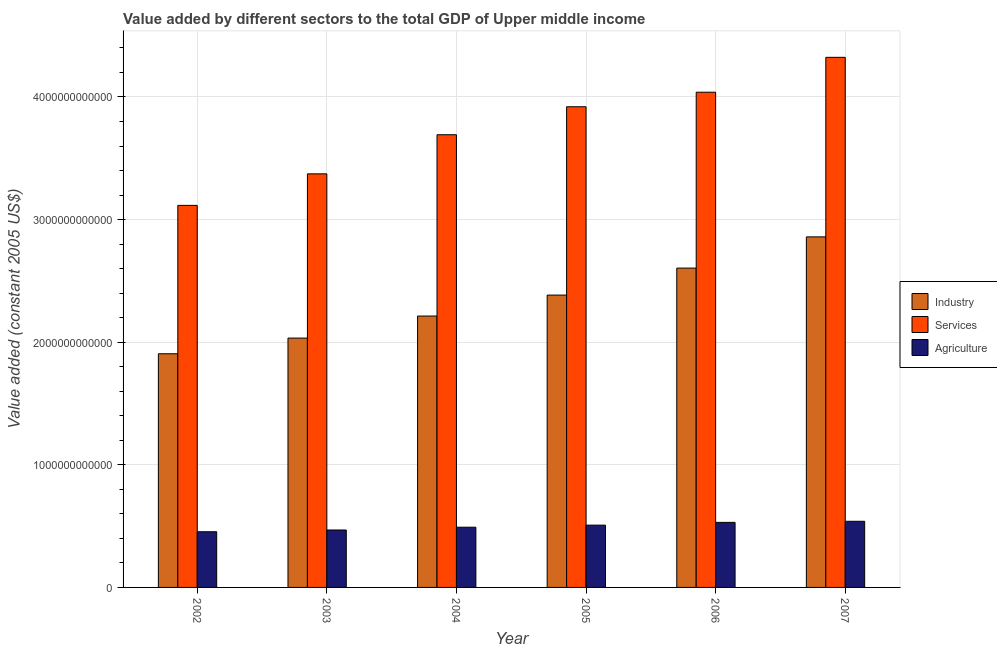How many different coloured bars are there?
Your answer should be compact. 3. How many groups of bars are there?
Give a very brief answer. 6. Are the number of bars per tick equal to the number of legend labels?
Give a very brief answer. Yes. Are the number of bars on each tick of the X-axis equal?
Keep it short and to the point. Yes. How many bars are there on the 6th tick from the right?
Keep it short and to the point. 3. What is the label of the 4th group of bars from the left?
Keep it short and to the point. 2005. What is the value added by agricultural sector in 2006?
Your answer should be very brief. 5.30e+11. Across all years, what is the maximum value added by services?
Offer a very short reply. 4.32e+12. Across all years, what is the minimum value added by industrial sector?
Provide a short and direct response. 1.91e+12. In which year was the value added by services maximum?
Your response must be concise. 2007. In which year was the value added by services minimum?
Give a very brief answer. 2002. What is the total value added by industrial sector in the graph?
Offer a terse response. 1.40e+13. What is the difference between the value added by industrial sector in 2004 and that in 2005?
Give a very brief answer. -1.71e+11. What is the difference between the value added by agricultural sector in 2007 and the value added by industrial sector in 2003?
Offer a terse response. 7.10e+1. What is the average value added by services per year?
Ensure brevity in your answer.  3.74e+12. In the year 2005, what is the difference between the value added by services and value added by agricultural sector?
Make the answer very short. 0. What is the ratio of the value added by services in 2003 to that in 2005?
Give a very brief answer. 0.86. Is the difference between the value added by services in 2004 and 2005 greater than the difference between the value added by industrial sector in 2004 and 2005?
Give a very brief answer. No. What is the difference between the highest and the second highest value added by agricultural sector?
Give a very brief answer. 8.90e+09. What is the difference between the highest and the lowest value added by services?
Provide a short and direct response. 1.21e+12. Is the sum of the value added by industrial sector in 2002 and 2006 greater than the maximum value added by agricultural sector across all years?
Offer a very short reply. Yes. What does the 3rd bar from the left in 2006 represents?
Keep it short and to the point. Agriculture. What does the 2nd bar from the right in 2006 represents?
Your answer should be compact. Services. Is it the case that in every year, the sum of the value added by industrial sector and value added by services is greater than the value added by agricultural sector?
Offer a very short reply. Yes. How many bars are there?
Your answer should be very brief. 18. How many years are there in the graph?
Keep it short and to the point. 6. What is the difference between two consecutive major ticks on the Y-axis?
Make the answer very short. 1.00e+12. Are the values on the major ticks of Y-axis written in scientific E-notation?
Offer a terse response. No. Does the graph contain any zero values?
Provide a succinct answer. No. Does the graph contain grids?
Provide a succinct answer. Yes. Where does the legend appear in the graph?
Make the answer very short. Center right. How many legend labels are there?
Your answer should be very brief. 3. How are the legend labels stacked?
Give a very brief answer. Vertical. What is the title of the graph?
Your response must be concise. Value added by different sectors to the total GDP of Upper middle income. What is the label or title of the Y-axis?
Provide a short and direct response. Value added (constant 2005 US$). What is the Value added (constant 2005 US$) in Industry in 2002?
Your answer should be very brief. 1.91e+12. What is the Value added (constant 2005 US$) in Services in 2002?
Offer a very short reply. 3.12e+12. What is the Value added (constant 2005 US$) in Agriculture in 2002?
Your response must be concise. 4.54e+11. What is the Value added (constant 2005 US$) in Industry in 2003?
Provide a short and direct response. 2.03e+12. What is the Value added (constant 2005 US$) of Services in 2003?
Keep it short and to the point. 3.37e+12. What is the Value added (constant 2005 US$) in Agriculture in 2003?
Ensure brevity in your answer.  4.68e+11. What is the Value added (constant 2005 US$) in Industry in 2004?
Give a very brief answer. 2.21e+12. What is the Value added (constant 2005 US$) of Services in 2004?
Keep it short and to the point. 3.69e+12. What is the Value added (constant 2005 US$) of Agriculture in 2004?
Keep it short and to the point. 4.91e+11. What is the Value added (constant 2005 US$) in Industry in 2005?
Your response must be concise. 2.38e+12. What is the Value added (constant 2005 US$) in Services in 2005?
Offer a very short reply. 3.92e+12. What is the Value added (constant 2005 US$) of Agriculture in 2005?
Provide a short and direct response. 5.08e+11. What is the Value added (constant 2005 US$) of Industry in 2006?
Make the answer very short. 2.60e+12. What is the Value added (constant 2005 US$) of Services in 2006?
Make the answer very short. 4.04e+12. What is the Value added (constant 2005 US$) of Agriculture in 2006?
Your answer should be very brief. 5.30e+11. What is the Value added (constant 2005 US$) of Industry in 2007?
Provide a short and direct response. 2.86e+12. What is the Value added (constant 2005 US$) of Services in 2007?
Your response must be concise. 4.32e+12. What is the Value added (constant 2005 US$) of Agriculture in 2007?
Your answer should be compact. 5.39e+11. Across all years, what is the maximum Value added (constant 2005 US$) of Industry?
Provide a short and direct response. 2.86e+12. Across all years, what is the maximum Value added (constant 2005 US$) of Services?
Your answer should be very brief. 4.32e+12. Across all years, what is the maximum Value added (constant 2005 US$) in Agriculture?
Your answer should be compact. 5.39e+11. Across all years, what is the minimum Value added (constant 2005 US$) of Industry?
Keep it short and to the point. 1.91e+12. Across all years, what is the minimum Value added (constant 2005 US$) of Services?
Your answer should be very brief. 3.12e+12. Across all years, what is the minimum Value added (constant 2005 US$) of Agriculture?
Provide a short and direct response. 4.54e+11. What is the total Value added (constant 2005 US$) in Industry in the graph?
Provide a succinct answer. 1.40e+13. What is the total Value added (constant 2005 US$) of Services in the graph?
Keep it short and to the point. 2.25e+13. What is the total Value added (constant 2005 US$) of Agriculture in the graph?
Your answer should be very brief. 2.99e+12. What is the difference between the Value added (constant 2005 US$) in Industry in 2002 and that in 2003?
Offer a terse response. -1.28e+11. What is the difference between the Value added (constant 2005 US$) of Services in 2002 and that in 2003?
Keep it short and to the point. -2.57e+11. What is the difference between the Value added (constant 2005 US$) of Agriculture in 2002 and that in 2003?
Offer a very short reply. -1.43e+1. What is the difference between the Value added (constant 2005 US$) of Industry in 2002 and that in 2004?
Your answer should be very brief. -3.08e+11. What is the difference between the Value added (constant 2005 US$) in Services in 2002 and that in 2004?
Offer a very short reply. -5.76e+11. What is the difference between the Value added (constant 2005 US$) of Agriculture in 2002 and that in 2004?
Your answer should be very brief. -3.70e+1. What is the difference between the Value added (constant 2005 US$) in Industry in 2002 and that in 2005?
Offer a terse response. -4.79e+11. What is the difference between the Value added (constant 2005 US$) in Services in 2002 and that in 2005?
Your response must be concise. -8.04e+11. What is the difference between the Value added (constant 2005 US$) of Agriculture in 2002 and that in 2005?
Offer a terse response. -5.39e+1. What is the difference between the Value added (constant 2005 US$) of Industry in 2002 and that in 2006?
Your response must be concise. -6.99e+11. What is the difference between the Value added (constant 2005 US$) in Services in 2002 and that in 2006?
Offer a terse response. -9.23e+11. What is the difference between the Value added (constant 2005 US$) in Agriculture in 2002 and that in 2006?
Ensure brevity in your answer.  -7.63e+1. What is the difference between the Value added (constant 2005 US$) of Industry in 2002 and that in 2007?
Offer a terse response. -9.53e+11. What is the difference between the Value added (constant 2005 US$) in Services in 2002 and that in 2007?
Offer a terse response. -1.21e+12. What is the difference between the Value added (constant 2005 US$) in Agriculture in 2002 and that in 2007?
Keep it short and to the point. -8.52e+1. What is the difference between the Value added (constant 2005 US$) in Industry in 2003 and that in 2004?
Your answer should be compact. -1.80e+11. What is the difference between the Value added (constant 2005 US$) of Services in 2003 and that in 2004?
Make the answer very short. -3.19e+11. What is the difference between the Value added (constant 2005 US$) in Agriculture in 2003 and that in 2004?
Give a very brief answer. -2.27e+1. What is the difference between the Value added (constant 2005 US$) of Industry in 2003 and that in 2005?
Give a very brief answer. -3.51e+11. What is the difference between the Value added (constant 2005 US$) in Services in 2003 and that in 2005?
Your response must be concise. -5.47e+11. What is the difference between the Value added (constant 2005 US$) in Agriculture in 2003 and that in 2005?
Provide a short and direct response. -3.96e+1. What is the difference between the Value added (constant 2005 US$) in Industry in 2003 and that in 2006?
Offer a very short reply. -5.71e+11. What is the difference between the Value added (constant 2005 US$) in Services in 2003 and that in 2006?
Your answer should be very brief. -6.66e+11. What is the difference between the Value added (constant 2005 US$) in Agriculture in 2003 and that in 2006?
Your answer should be compact. -6.21e+1. What is the difference between the Value added (constant 2005 US$) in Industry in 2003 and that in 2007?
Give a very brief answer. -8.25e+11. What is the difference between the Value added (constant 2005 US$) of Services in 2003 and that in 2007?
Offer a very short reply. -9.50e+11. What is the difference between the Value added (constant 2005 US$) in Agriculture in 2003 and that in 2007?
Provide a short and direct response. -7.10e+1. What is the difference between the Value added (constant 2005 US$) in Industry in 2004 and that in 2005?
Provide a succinct answer. -1.71e+11. What is the difference between the Value added (constant 2005 US$) in Services in 2004 and that in 2005?
Your response must be concise. -2.28e+11. What is the difference between the Value added (constant 2005 US$) in Agriculture in 2004 and that in 2005?
Keep it short and to the point. -1.69e+1. What is the difference between the Value added (constant 2005 US$) of Industry in 2004 and that in 2006?
Keep it short and to the point. -3.91e+11. What is the difference between the Value added (constant 2005 US$) of Services in 2004 and that in 2006?
Ensure brevity in your answer.  -3.47e+11. What is the difference between the Value added (constant 2005 US$) of Agriculture in 2004 and that in 2006?
Provide a succinct answer. -3.94e+1. What is the difference between the Value added (constant 2005 US$) of Industry in 2004 and that in 2007?
Your answer should be very brief. -6.46e+11. What is the difference between the Value added (constant 2005 US$) of Services in 2004 and that in 2007?
Provide a succinct answer. -6.31e+11. What is the difference between the Value added (constant 2005 US$) in Agriculture in 2004 and that in 2007?
Offer a terse response. -4.83e+1. What is the difference between the Value added (constant 2005 US$) of Industry in 2005 and that in 2006?
Keep it short and to the point. -2.20e+11. What is the difference between the Value added (constant 2005 US$) of Services in 2005 and that in 2006?
Ensure brevity in your answer.  -1.19e+11. What is the difference between the Value added (constant 2005 US$) of Agriculture in 2005 and that in 2006?
Give a very brief answer. -2.25e+1. What is the difference between the Value added (constant 2005 US$) in Industry in 2005 and that in 2007?
Provide a succinct answer. -4.75e+11. What is the difference between the Value added (constant 2005 US$) in Services in 2005 and that in 2007?
Your answer should be compact. -4.03e+11. What is the difference between the Value added (constant 2005 US$) in Agriculture in 2005 and that in 2007?
Your response must be concise. -3.14e+1. What is the difference between the Value added (constant 2005 US$) in Industry in 2006 and that in 2007?
Keep it short and to the point. -2.55e+11. What is the difference between the Value added (constant 2005 US$) in Services in 2006 and that in 2007?
Keep it short and to the point. -2.84e+11. What is the difference between the Value added (constant 2005 US$) of Agriculture in 2006 and that in 2007?
Provide a short and direct response. -8.90e+09. What is the difference between the Value added (constant 2005 US$) of Industry in 2002 and the Value added (constant 2005 US$) of Services in 2003?
Offer a very short reply. -1.47e+12. What is the difference between the Value added (constant 2005 US$) of Industry in 2002 and the Value added (constant 2005 US$) of Agriculture in 2003?
Offer a very short reply. 1.44e+12. What is the difference between the Value added (constant 2005 US$) of Services in 2002 and the Value added (constant 2005 US$) of Agriculture in 2003?
Make the answer very short. 2.65e+12. What is the difference between the Value added (constant 2005 US$) in Industry in 2002 and the Value added (constant 2005 US$) in Services in 2004?
Ensure brevity in your answer.  -1.79e+12. What is the difference between the Value added (constant 2005 US$) in Industry in 2002 and the Value added (constant 2005 US$) in Agriculture in 2004?
Your answer should be compact. 1.41e+12. What is the difference between the Value added (constant 2005 US$) in Services in 2002 and the Value added (constant 2005 US$) in Agriculture in 2004?
Your answer should be compact. 2.62e+12. What is the difference between the Value added (constant 2005 US$) of Industry in 2002 and the Value added (constant 2005 US$) of Services in 2005?
Your answer should be compact. -2.01e+12. What is the difference between the Value added (constant 2005 US$) of Industry in 2002 and the Value added (constant 2005 US$) of Agriculture in 2005?
Make the answer very short. 1.40e+12. What is the difference between the Value added (constant 2005 US$) of Services in 2002 and the Value added (constant 2005 US$) of Agriculture in 2005?
Your answer should be compact. 2.61e+12. What is the difference between the Value added (constant 2005 US$) of Industry in 2002 and the Value added (constant 2005 US$) of Services in 2006?
Your answer should be very brief. -2.13e+12. What is the difference between the Value added (constant 2005 US$) in Industry in 2002 and the Value added (constant 2005 US$) in Agriculture in 2006?
Your response must be concise. 1.38e+12. What is the difference between the Value added (constant 2005 US$) in Services in 2002 and the Value added (constant 2005 US$) in Agriculture in 2006?
Make the answer very short. 2.59e+12. What is the difference between the Value added (constant 2005 US$) in Industry in 2002 and the Value added (constant 2005 US$) in Services in 2007?
Your response must be concise. -2.42e+12. What is the difference between the Value added (constant 2005 US$) in Industry in 2002 and the Value added (constant 2005 US$) in Agriculture in 2007?
Your response must be concise. 1.37e+12. What is the difference between the Value added (constant 2005 US$) in Services in 2002 and the Value added (constant 2005 US$) in Agriculture in 2007?
Provide a succinct answer. 2.58e+12. What is the difference between the Value added (constant 2005 US$) in Industry in 2003 and the Value added (constant 2005 US$) in Services in 2004?
Offer a terse response. -1.66e+12. What is the difference between the Value added (constant 2005 US$) of Industry in 2003 and the Value added (constant 2005 US$) of Agriculture in 2004?
Your response must be concise. 1.54e+12. What is the difference between the Value added (constant 2005 US$) of Services in 2003 and the Value added (constant 2005 US$) of Agriculture in 2004?
Offer a very short reply. 2.88e+12. What is the difference between the Value added (constant 2005 US$) of Industry in 2003 and the Value added (constant 2005 US$) of Services in 2005?
Offer a very short reply. -1.89e+12. What is the difference between the Value added (constant 2005 US$) of Industry in 2003 and the Value added (constant 2005 US$) of Agriculture in 2005?
Offer a very short reply. 1.53e+12. What is the difference between the Value added (constant 2005 US$) of Services in 2003 and the Value added (constant 2005 US$) of Agriculture in 2005?
Your response must be concise. 2.87e+12. What is the difference between the Value added (constant 2005 US$) in Industry in 2003 and the Value added (constant 2005 US$) in Services in 2006?
Your answer should be very brief. -2.01e+12. What is the difference between the Value added (constant 2005 US$) of Industry in 2003 and the Value added (constant 2005 US$) of Agriculture in 2006?
Offer a very short reply. 1.50e+12. What is the difference between the Value added (constant 2005 US$) of Services in 2003 and the Value added (constant 2005 US$) of Agriculture in 2006?
Provide a succinct answer. 2.84e+12. What is the difference between the Value added (constant 2005 US$) of Industry in 2003 and the Value added (constant 2005 US$) of Services in 2007?
Provide a short and direct response. -2.29e+12. What is the difference between the Value added (constant 2005 US$) of Industry in 2003 and the Value added (constant 2005 US$) of Agriculture in 2007?
Make the answer very short. 1.49e+12. What is the difference between the Value added (constant 2005 US$) in Services in 2003 and the Value added (constant 2005 US$) in Agriculture in 2007?
Provide a short and direct response. 2.83e+12. What is the difference between the Value added (constant 2005 US$) in Industry in 2004 and the Value added (constant 2005 US$) in Services in 2005?
Offer a very short reply. -1.71e+12. What is the difference between the Value added (constant 2005 US$) of Industry in 2004 and the Value added (constant 2005 US$) of Agriculture in 2005?
Give a very brief answer. 1.71e+12. What is the difference between the Value added (constant 2005 US$) of Services in 2004 and the Value added (constant 2005 US$) of Agriculture in 2005?
Provide a succinct answer. 3.18e+12. What is the difference between the Value added (constant 2005 US$) in Industry in 2004 and the Value added (constant 2005 US$) in Services in 2006?
Your response must be concise. -1.83e+12. What is the difference between the Value added (constant 2005 US$) of Industry in 2004 and the Value added (constant 2005 US$) of Agriculture in 2006?
Provide a succinct answer. 1.68e+12. What is the difference between the Value added (constant 2005 US$) in Services in 2004 and the Value added (constant 2005 US$) in Agriculture in 2006?
Your answer should be compact. 3.16e+12. What is the difference between the Value added (constant 2005 US$) of Industry in 2004 and the Value added (constant 2005 US$) of Services in 2007?
Ensure brevity in your answer.  -2.11e+12. What is the difference between the Value added (constant 2005 US$) in Industry in 2004 and the Value added (constant 2005 US$) in Agriculture in 2007?
Keep it short and to the point. 1.67e+12. What is the difference between the Value added (constant 2005 US$) in Services in 2004 and the Value added (constant 2005 US$) in Agriculture in 2007?
Provide a succinct answer. 3.15e+12. What is the difference between the Value added (constant 2005 US$) of Industry in 2005 and the Value added (constant 2005 US$) of Services in 2006?
Offer a terse response. -1.65e+12. What is the difference between the Value added (constant 2005 US$) in Industry in 2005 and the Value added (constant 2005 US$) in Agriculture in 2006?
Your answer should be compact. 1.85e+12. What is the difference between the Value added (constant 2005 US$) of Services in 2005 and the Value added (constant 2005 US$) of Agriculture in 2006?
Offer a terse response. 3.39e+12. What is the difference between the Value added (constant 2005 US$) in Industry in 2005 and the Value added (constant 2005 US$) in Services in 2007?
Ensure brevity in your answer.  -1.94e+12. What is the difference between the Value added (constant 2005 US$) of Industry in 2005 and the Value added (constant 2005 US$) of Agriculture in 2007?
Offer a terse response. 1.85e+12. What is the difference between the Value added (constant 2005 US$) in Services in 2005 and the Value added (constant 2005 US$) in Agriculture in 2007?
Offer a terse response. 3.38e+12. What is the difference between the Value added (constant 2005 US$) in Industry in 2006 and the Value added (constant 2005 US$) in Services in 2007?
Your answer should be compact. -1.72e+12. What is the difference between the Value added (constant 2005 US$) in Industry in 2006 and the Value added (constant 2005 US$) in Agriculture in 2007?
Provide a short and direct response. 2.07e+12. What is the difference between the Value added (constant 2005 US$) in Services in 2006 and the Value added (constant 2005 US$) in Agriculture in 2007?
Your answer should be compact. 3.50e+12. What is the average Value added (constant 2005 US$) of Industry per year?
Make the answer very short. 2.33e+12. What is the average Value added (constant 2005 US$) in Services per year?
Keep it short and to the point. 3.74e+12. What is the average Value added (constant 2005 US$) in Agriculture per year?
Ensure brevity in your answer.  4.99e+11. In the year 2002, what is the difference between the Value added (constant 2005 US$) of Industry and Value added (constant 2005 US$) of Services?
Keep it short and to the point. -1.21e+12. In the year 2002, what is the difference between the Value added (constant 2005 US$) of Industry and Value added (constant 2005 US$) of Agriculture?
Offer a very short reply. 1.45e+12. In the year 2002, what is the difference between the Value added (constant 2005 US$) of Services and Value added (constant 2005 US$) of Agriculture?
Provide a short and direct response. 2.66e+12. In the year 2003, what is the difference between the Value added (constant 2005 US$) in Industry and Value added (constant 2005 US$) in Services?
Offer a terse response. -1.34e+12. In the year 2003, what is the difference between the Value added (constant 2005 US$) of Industry and Value added (constant 2005 US$) of Agriculture?
Offer a terse response. 1.57e+12. In the year 2003, what is the difference between the Value added (constant 2005 US$) of Services and Value added (constant 2005 US$) of Agriculture?
Your response must be concise. 2.90e+12. In the year 2004, what is the difference between the Value added (constant 2005 US$) of Industry and Value added (constant 2005 US$) of Services?
Provide a succinct answer. -1.48e+12. In the year 2004, what is the difference between the Value added (constant 2005 US$) of Industry and Value added (constant 2005 US$) of Agriculture?
Offer a terse response. 1.72e+12. In the year 2004, what is the difference between the Value added (constant 2005 US$) of Services and Value added (constant 2005 US$) of Agriculture?
Keep it short and to the point. 3.20e+12. In the year 2005, what is the difference between the Value added (constant 2005 US$) in Industry and Value added (constant 2005 US$) in Services?
Offer a terse response. -1.54e+12. In the year 2005, what is the difference between the Value added (constant 2005 US$) of Industry and Value added (constant 2005 US$) of Agriculture?
Keep it short and to the point. 1.88e+12. In the year 2005, what is the difference between the Value added (constant 2005 US$) of Services and Value added (constant 2005 US$) of Agriculture?
Your answer should be very brief. 3.41e+12. In the year 2006, what is the difference between the Value added (constant 2005 US$) of Industry and Value added (constant 2005 US$) of Services?
Make the answer very short. -1.43e+12. In the year 2006, what is the difference between the Value added (constant 2005 US$) in Industry and Value added (constant 2005 US$) in Agriculture?
Provide a succinct answer. 2.07e+12. In the year 2006, what is the difference between the Value added (constant 2005 US$) of Services and Value added (constant 2005 US$) of Agriculture?
Provide a short and direct response. 3.51e+12. In the year 2007, what is the difference between the Value added (constant 2005 US$) of Industry and Value added (constant 2005 US$) of Services?
Ensure brevity in your answer.  -1.46e+12. In the year 2007, what is the difference between the Value added (constant 2005 US$) of Industry and Value added (constant 2005 US$) of Agriculture?
Keep it short and to the point. 2.32e+12. In the year 2007, what is the difference between the Value added (constant 2005 US$) in Services and Value added (constant 2005 US$) in Agriculture?
Ensure brevity in your answer.  3.78e+12. What is the ratio of the Value added (constant 2005 US$) of Industry in 2002 to that in 2003?
Offer a terse response. 0.94. What is the ratio of the Value added (constant 2005 US$) of Services in 2002 to that in 2003?
Offer a terse response. 0.92. What is the ratio of the Value added (constant 2005 US$) in Agriculture in 2002 to that in 2003?
Your response must be concise. 0.97. What is the ratio of the Value added (constant 2005 US$) of Industry in 2002 to that in 2004?
Your answer should be compact. 0.86. What is the ratio of the Value added (constant 2005 US$) of Services in 2002 to that in 2004?
Your response must be concise. 0.84. What is the ratio of the Value added (constant 2005 US$) in Agriculture in 2002 to that in 2004?
Provide a short and direct response. 0.92. What is the ratio of the Value added (constant 2005 US$) in Industry in 2002 to that in 2005?
Give a very brief answer. 0.8. What is the ratio of the Value added (constant 2005 US$) of Services in 2002 to that in 2005?
Offer a very short reply. 0.79. What is the ratio of the Value added (constant 2005 US$) of Agriculture in 2002 to that in 2005?
Ensure brevity in your answer.  0.89. What is the ratio of the Value added (constant 2005 US$) of Industry in 2002 to that in 2006?
Provide a succinct answer. 0.73. What is the ratio of the Value added (constant 2005 US$) of Services in 2002 to that in 2006?
Offer a terse response. 0.77. What is the ratio of the Value added (constant 2005 US$) of Agriculture in 2002 to that in 2006?
Make the answer very short. 0.86. What is the ratio of the Value added (constant 2005 US$) in Industry in 2002 to that in 2007?
Your response must be concise. 0.67. What is the ratio of the Value added (constant 2005 US$) in Services in 2002 to that in 2007?
Keep it short and to the point. 0.72. What is the ratio of the Value added (constant 2005 US$) of Agriculture in 2002 to that in 2007?
Your answer should be very brief. 0.84. What is the ratio of the Value added (constant 2005 US$) of Industry in 2003 to that in 2004?
Ensure brevity in your answer.  0.92. What is the ratio of the Value added (constant 2005 US$) in Services in 2003 to that in 2004?
Your response must be concise. 0.91. What is the ratio of the Value added (constant 2005 US$) in Agriculture in 2003 to that in 2004?
Your answer should be very brief. 0.95. What is the ratio of the Value added (constant 2005 US$) in Industry in 2003 to that in 2005?
Ensure brevity in your answer.  0.85. What is the ratio of the Value added (constant 2005 US$) in Services in 2003 to that in 2005?
Ensure brevity in your answer.  0.86. What is the ratio of the Value added (constant 2005 US$) in Agriculture in 2003 to that in 2005?
Ensure brevity in your answer.  0.92. What is the ratio of the Value added (constant 2005 US$) in Industry in 2003 to that in 2006?
Offer a very short reply. 0.78. What is the ratio of the Value added (constant 2005 US$) of Services in 2003 to that in 2006?
Offer a terse response. 0.84. What is the ratio of the Value added (constant 2005 US$) in Agriculture in 2003 to that in 2006?
Provide a succinct answer. 0.88. What is the ratio of the Value added (constant 2005 US$) in Industry in 2003 to that in 2007?
Your answer should be compact. 0.71. What is the ratio of the Value added (constant 2005 US$) in Services in 2003 to that in 2007?
Ensure brevity in your answer.  0.78. What is the ratio of the Value added (constant 2005 US$) in Agriculture in 2003 to that in 2007?
Ensure brevity in your answer.  0.87. What is the ratio of the Value added (constant 2005 US$) of Industry in 2004 to that in 2005?
Provide a succinct answer. 0.93. What is the ratio of the Value added (constant 2005 US$) of Services in 2004 to that in 2005?
Provide a short and direct response. 0.94. What is the ratio of the Value added (constant 2005 US$) in Agriculture in 2004 to that in 2005?
Your response must be concise. 0.97. What is the ratio of the Value added (constant 2005 US$) in Industry in 2004 to that in 2006?
Offer a terse response. 0.85. What is the ratio of the Value added (constant 2005 US$) of Services in 2004 to that in 2006?
Offer a very short reply. 0.91. What is the ratio of the Value added (constant 2005 US$) of Agriculture in 2004 to that in 2006?
Offer a terse response. 0.93. What is the ratio of the Value added (constant 2005 US$) in Industry in 2004 to that in 2007?
Offer a very short reply. 0.77. What is the ratio of the Value added (constant 2005 US$) in Services in 2004 to that in 2007?
Ensure brevity in your answer.  0.85. What is the ratio of the Value added (constant 2005 US$) in Agriculture in 2004 to that in 2007?
Ensure brevity in your answer.  0.91. What is the ratio of the Value added (constant 2005 US$) in Industry in 2005 to that in 2006?
Provide a short and direct response. 0.92. What is the ratio of the Value added (constant 2005 US$) in Services in 2005 to that in 2006?
Provide a short and direct response. 0.97. What is the ratio of the Value added (constant 2005 US$) in Agriculture in 2005 to that in 2006?
Offer a very short reply. 0.96. What is the ratio of the Value added (constant 2005 US$) of Industry in 2005 to that in 2007?
Make the answer very short. 0.83. What is the ratio of the Value added (constant 2005 US$) in Services in 2005 to that in 2007?
Provide a short and direct response. 0.91. What is the ratio of the Value added (constant 2005 US$) in Agriculture in 2005 to that in 2007?
Your answer should be very brief. 0.94. What is the ratio of the Value added (constant 2005 US$) in Industry in 2006 to that in 2007?
Provide a short and direct response. 0.91. What is the ratio of the Value added (constant 2005 US$) of Services in 2006 to that in 2007?
Your response must be concise. 0.93. What is the ratio of the Value added (constant 2005 US$) in Agriculture in 2006 to that in 2007?
Your answer should be compact. 0.98. What is the difference between the highest and the second highest Value added (constant 2005 US$) in Industry?
Your answer should be compact. 2.55e+11. What is the difference between the highest and the second highest Value added (constant 2005 US$) in Services?
Make the answer very short. 2.84e+11. What is the difference between the highest and the second highest Value added (constant 2005 US$) in Agriculture?
Provide a succinct answer. 8.90e+09. What is the difference between the highest and the lowest Value added (constant 2005 US$) in Industry?
Your answer should be compact. 9.53e+11. What is the difference between the highest and the lowest Value added (constant 2005 US$) of Services?
Your answer should be compact. 1.21e+12. What is the difference between the highest and the lowest Value added (constant 2005 US$) in Agriculture?
Provide a short and direct response. 8.52e+1. 